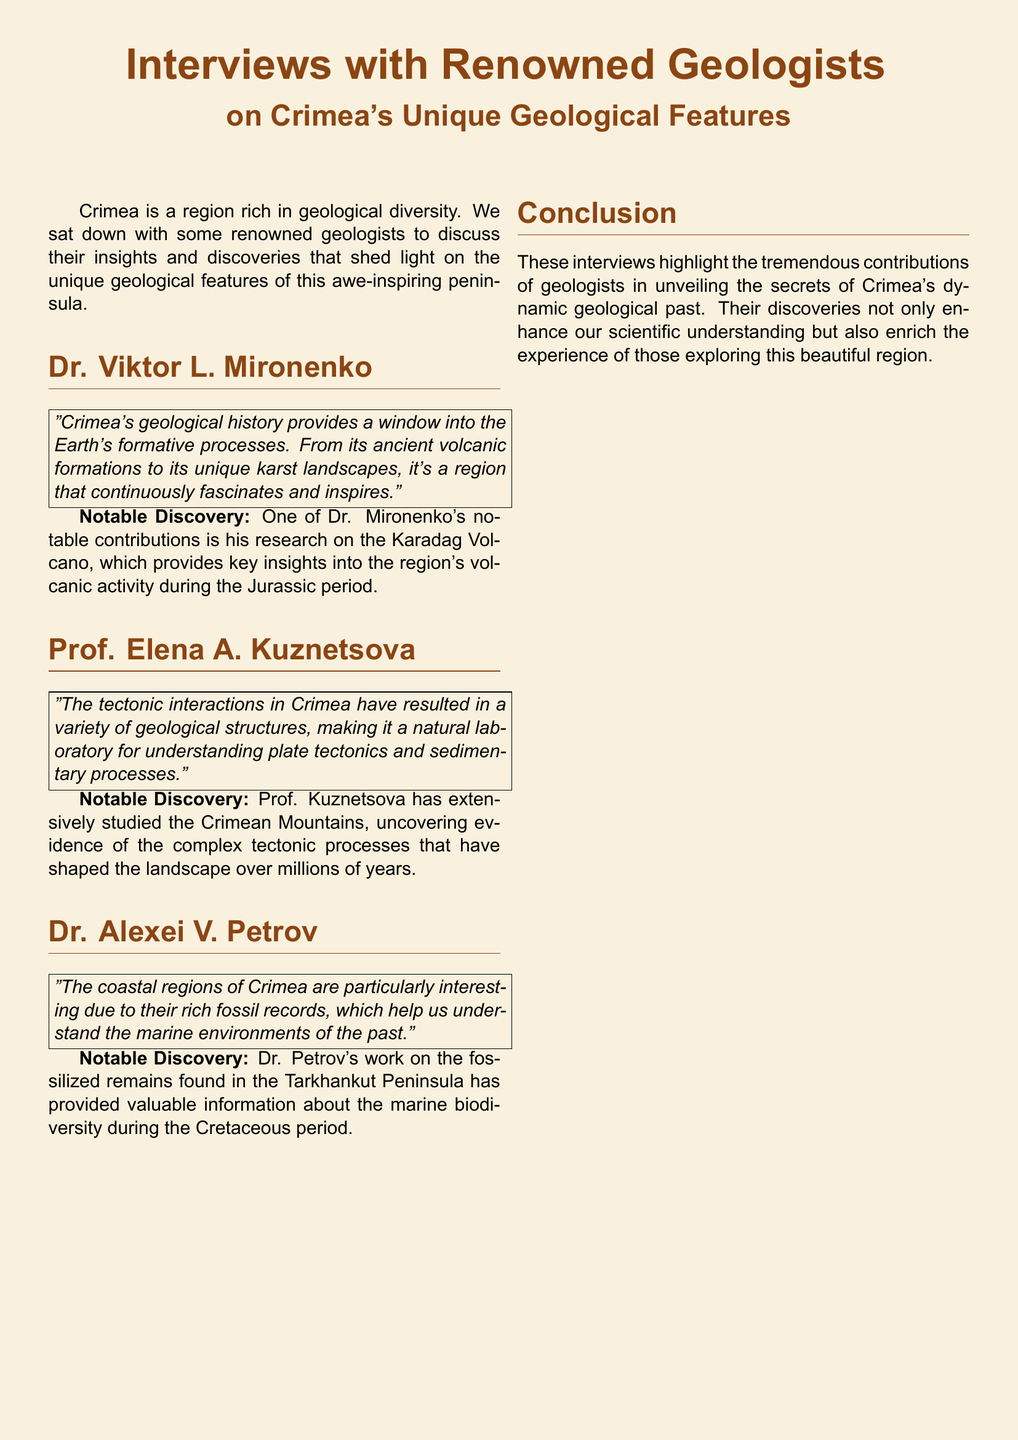What is the focus of the interviews? The interviews focus on geological features in Crimea, showcasing insights and discoveries from renowned geologists.
Answer: geological features in Crimea Who is the first geologist mentioned in the document? The first geologist mentioned is Dr. Viktor L. Mironenko.
Answer: Dr. Viktor L. Mironenko What notable discovery is attributed to Dr. Mironenko? Dr. Mironenko's notable discovery is his research on the Karadag Volcano during the Jurassic period.
Answer: research on the Karadag Volcano What does Prof. Kuznetsova study? Prof. Kuznetsova studies the Crimean Mountains and tectonic processes that shaped its landscape.
Answer: Crimean Mountains Which period does Dr. Petrov's research focus on? Dr. Petrov's research focuses on the Cretaceous period and marine environments.
Answer: Cretaceous period What type of landscapes are mentioned in Dr. Mironenko's quote? Dr. Mironenko mentions ancient volcanic formations and unique karst landscapes.
Answer: volcanic formations and karst landscapes How many geologists are interviewed in the document? There are three geologists interviewed in the document.
Answer: three What is the primary theme of the conclusion section? The primary theme of the conclusion section is the contributions of geologists to understanding Crimea's geological past.
Answer: contributions of geologists 